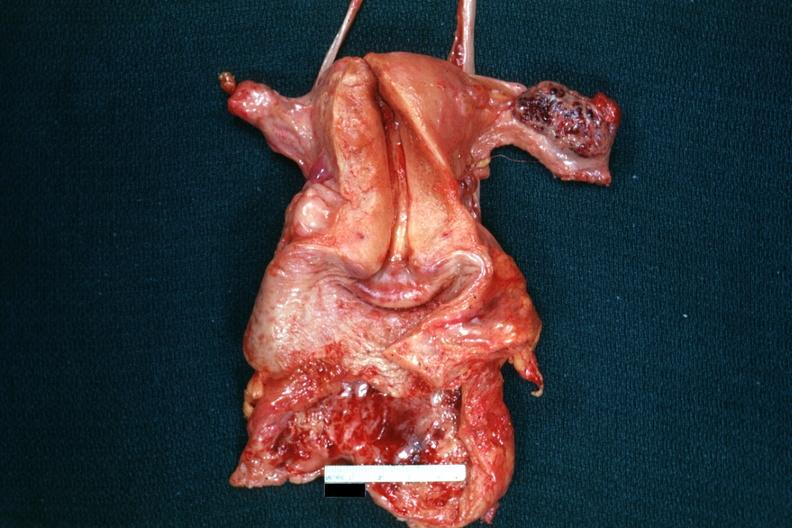does this image show opened uterus with adnexa and hemorrhagic mass in ovary?
Answer the question using a single word or phrase. Yes 